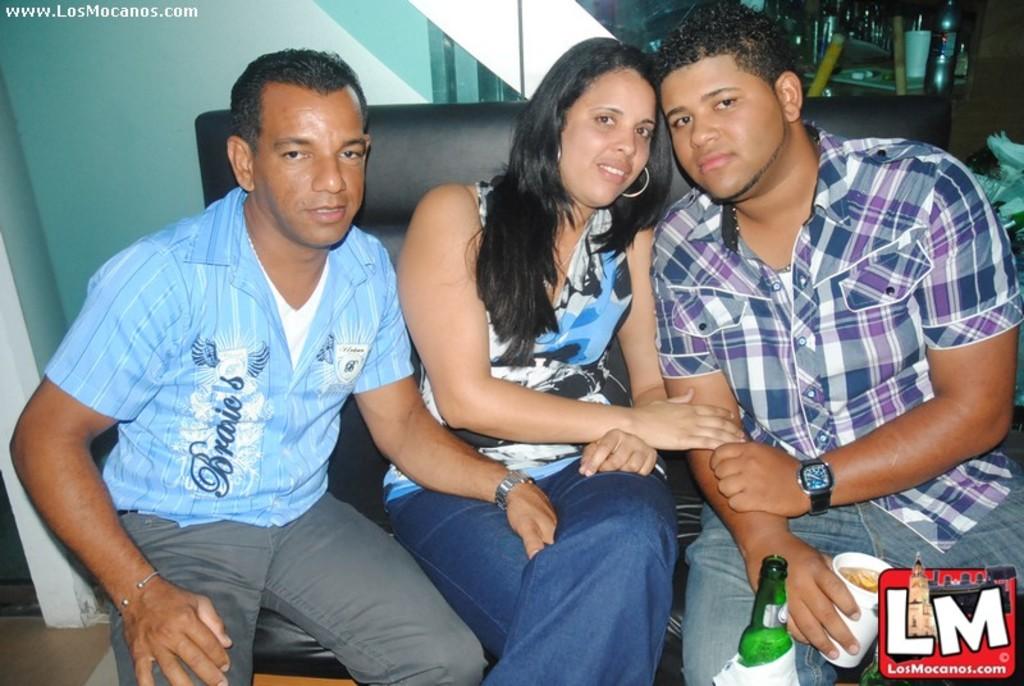What does his shirt say?
Provide a succinct answer. Unanswerable. 